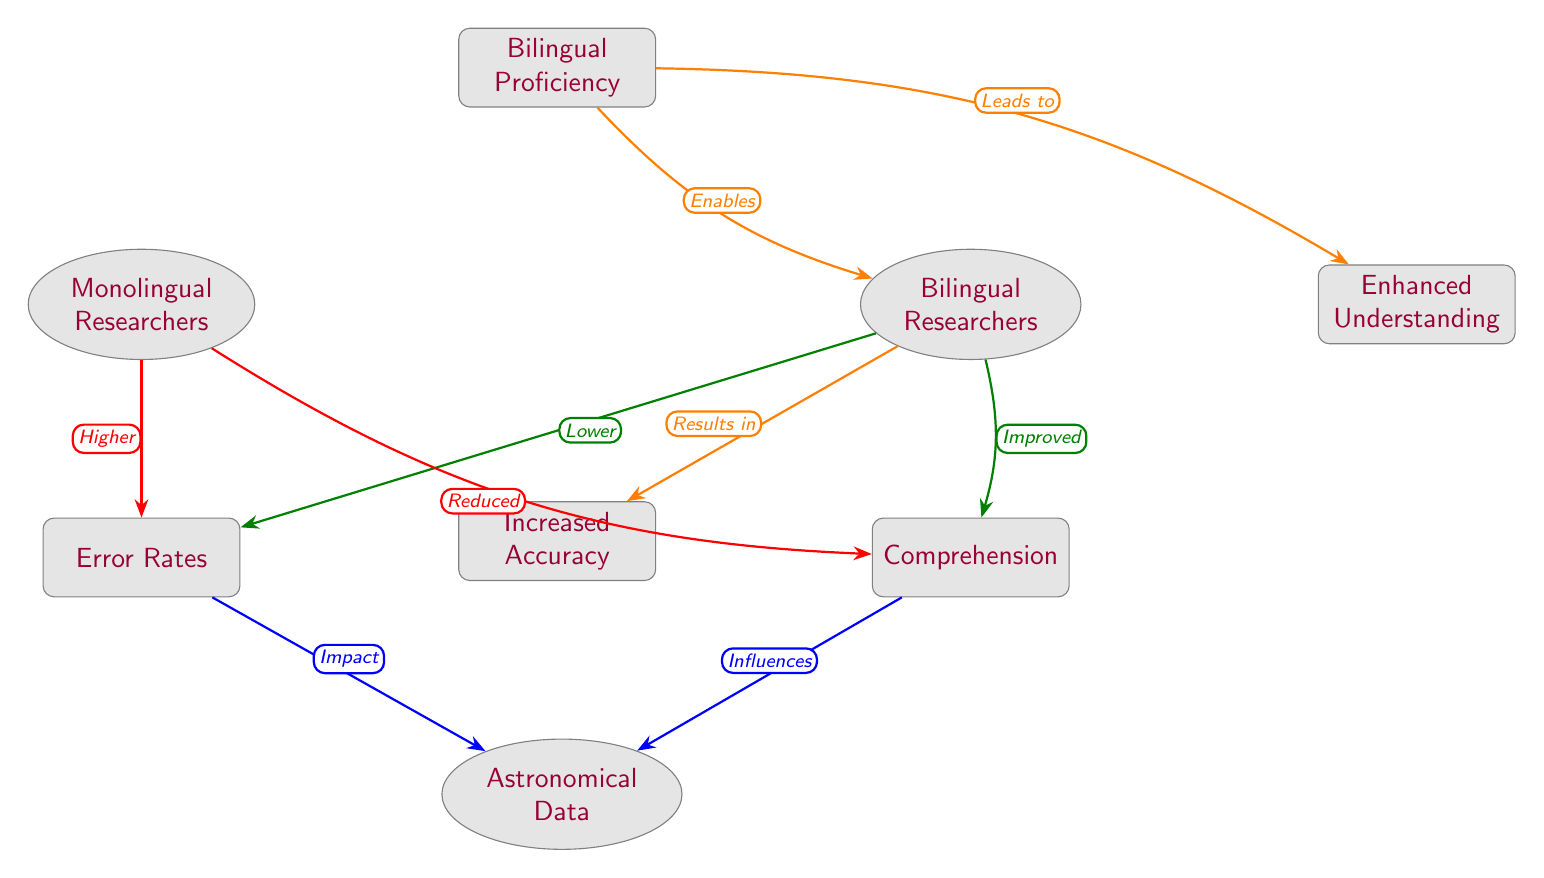What is the primary factor connecting bilingual proficiency to bilingual researchers? The diagram indicates that bilingual proficiency enables bilingual researchers, linking the two nodes directly with an orange, labeled arrow.
Answer: Enables What impact do bilingual researchers have on error rates? According to the diagram, the relationship between bilingual researchers and error rates shows that bilingual researchers result in lower error rates, as indicated by the green arrow pointing from bilingual researchers to error rates.
Answer: Lower How many nodes are there in total in the diagram? Counting all the individual shapes in the diagram, there are eight distinct nodes, which include various classifications like bilingual proficiency and error rates.
Answer: Eight What effect does comprehension have on astronomical data? The diagram shows that comprehension influences astronomical data, with a blue arrow indicating its direct relationship to astronomical data in the diagram.
Answer: Influences Which group exhibits higher error rates according to the diagram? The diagram indicates that monolingual researchers experience higher error rates, as shown by the red arrow that leads from monolingual researchers to the error rates node.
Answer: Higher How do bilingual researchers affect comprehension compared to monolingual researchers? Bilingual researchers lead to improved comprehension, while monolingual researchers result in reduced comprehension, as indicated by the arrows pointing in opposite directions from each researcher group to the comprehension node.
Answer: Improved What is the relationship between bilingual proficiency and enhanced understanding? The diagram shows an orange arrow from bilingual proficiency to enhanced understanding, labeled as "Leads to," which indicates a direct relationship between these two nodes.
Answer: Leads to What does increased accuracy relate to in the context of bilingual research? The diagram specifies that increased accuracy is a result of bilingual researchers, as indicated by the arrow leading from bilingual researchers to the increased accuracy node.
Answer: Results in 